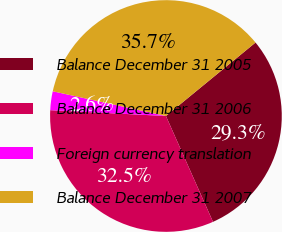Convert chart to OTSL. <chart><loc_0><loc_0><loc_500><loc_500><pie_chart><fcel>Balance December 31 2005<fcel>Balance December 31 2006<fcel>Foreign currency translation<fcel>Balance December 31 2007<nl><fcel>29.27%<fcel>32.46%<fcel>2.62%<fcel>35.65%<nl></chart> 